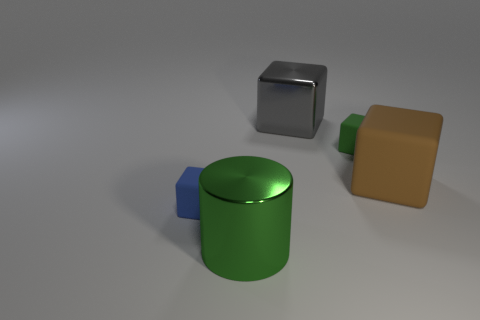How many other objects are there of the same material as the big brown block?
Offer a very short reply. 2. Is there any other thing that is the same shape as the green metal object?
Offer a very short reply. No. The tiny matte block that is left of the big cube that is behind the small cube right of the tiny blue object is what color?
Ensure brevity in your answer.  Blue. There is a big object that is left of the green block and in front of the green block; what shape is it?
Give a very brief answer. Cylinder. What is the color of the small block right of the shiny thing that is behind the big green cylinder?
Ensure brevity in your answer.  Green. There is a big metal object that is behind the tiny matte thing left of the metal thing behind the cylinder; what shape is it?
Keep it short and to the point. Cube. What size is the matte thing that is in front of the green matte thing and to the right of the gray metallic thing?
Ensure brevity in your answer.  Large. What number of other metallic cylinders are the same color as the metallic cylinder?
Offer a terse response. 0. What material is the gray block?
Provide a succinct answer. Metal. Do the small block that is behind the brown cube and the small blue thing have the same material?
Keep it short and to the point. Yes. 